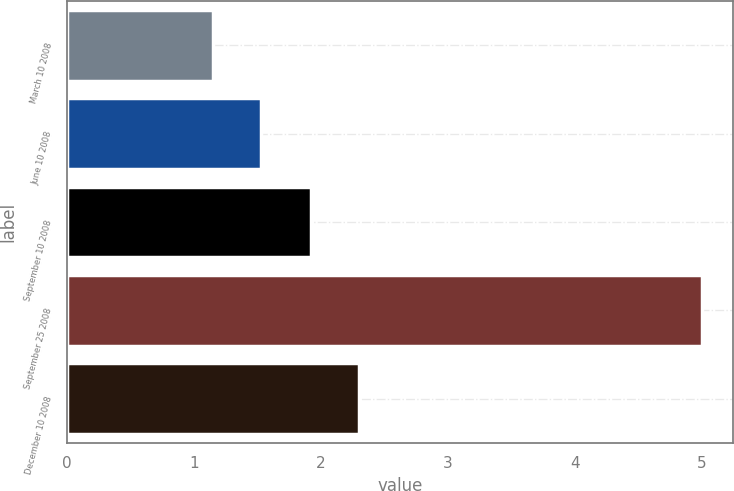Convert chart to OTSL. <chart><loc_0><loc_0><loc_500><loc_500><bar_chart><fcel>March 10 2008<fcel>June 10 2008<fcel>September 10 2008<fcel>September 25 2008<fcel>December 10 2008<nl><fcel>1.15<fcel>1.53<fcel>1.92<fcel>5<fcel>2.3<nl></chart> 